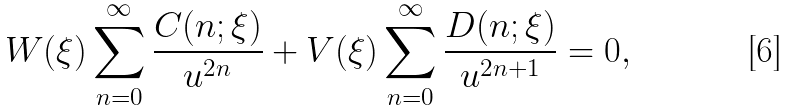Convert formula to latex. <formula><loc_0><loc_0><loc_500><loc_500>W ( \xi ) \sum _ { n = 0 } ^ { \infty } \frac { C ( n ; \xi ) } { u ^ { 2 n } } + V ( \xi ) \sum _ { n = 0 } ^ { \infty } \frac { D ( n ; \xi ) } { u ^ { 2 n + 1 } } = 0 ,</formula> 